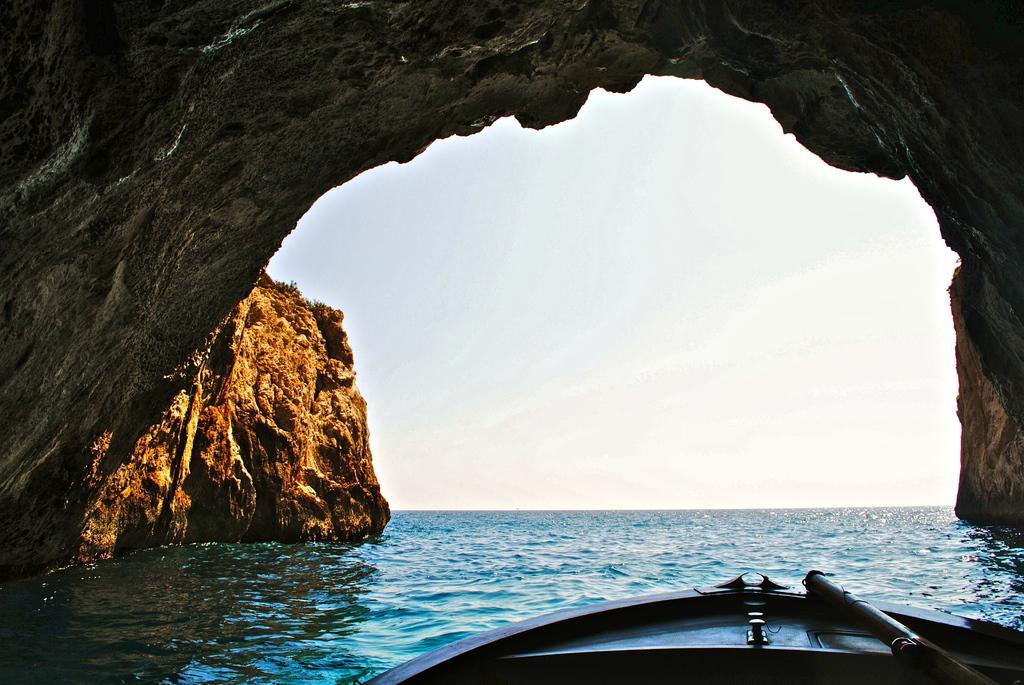In one or two sentences, can you explain what this image depicts? In this image, I think these are the hills. It is a kind of a cave. I can see the water flowing. At the bottom of the image, that looks like a boat. Here is the sky. 